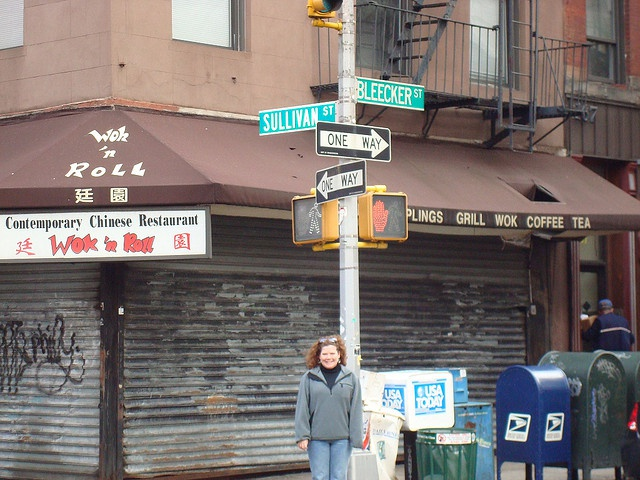Describe the objects in this image and their specific colors. I can see people in lightgray, darkgray, and gray tones, people in lightgray, black, navy, gray, and maroon tones, traffic light in lightgray, gray, and tan tones, and traffic light in lightgray, orange, olive, and black tones in this image. 